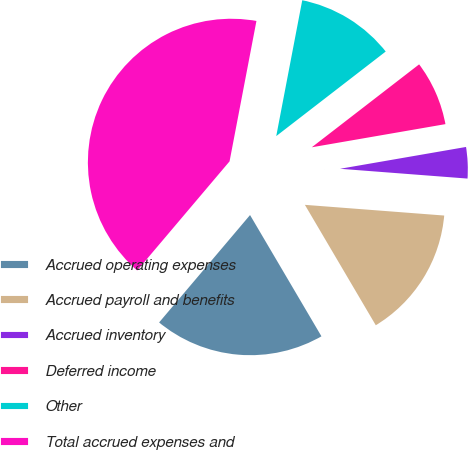Convert chart to OTSL. <chart><loc_0><loc_0><loc_500><loc_500><pie_chart><fcel>Accrued operating expenses<fcel>Accrued payroll and benefits<fcel>Accrued inventory<fcel>Deferred income<fcel>Other<fcel>Total accrued expenses and<nl><fcel>19.65%<fcel>15.31%<fcel>3.95%<fcel>7.74%<fcel>11.52%<fcel>41.83%<nl></chart> 